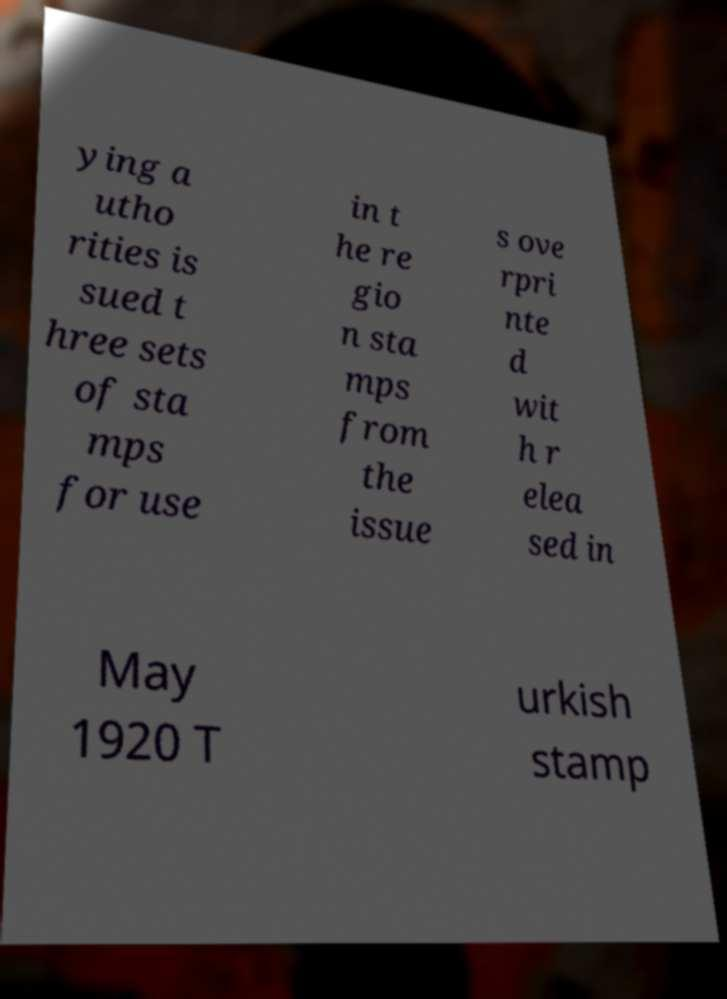Please identify and transcribe the text found in this image. ying a utho rities is sued t hree sets of sta mps for use in t he re gio n sta mps from the issue s ove rpri nte d wit h r elea sed in May 1920 T urkish stamp 